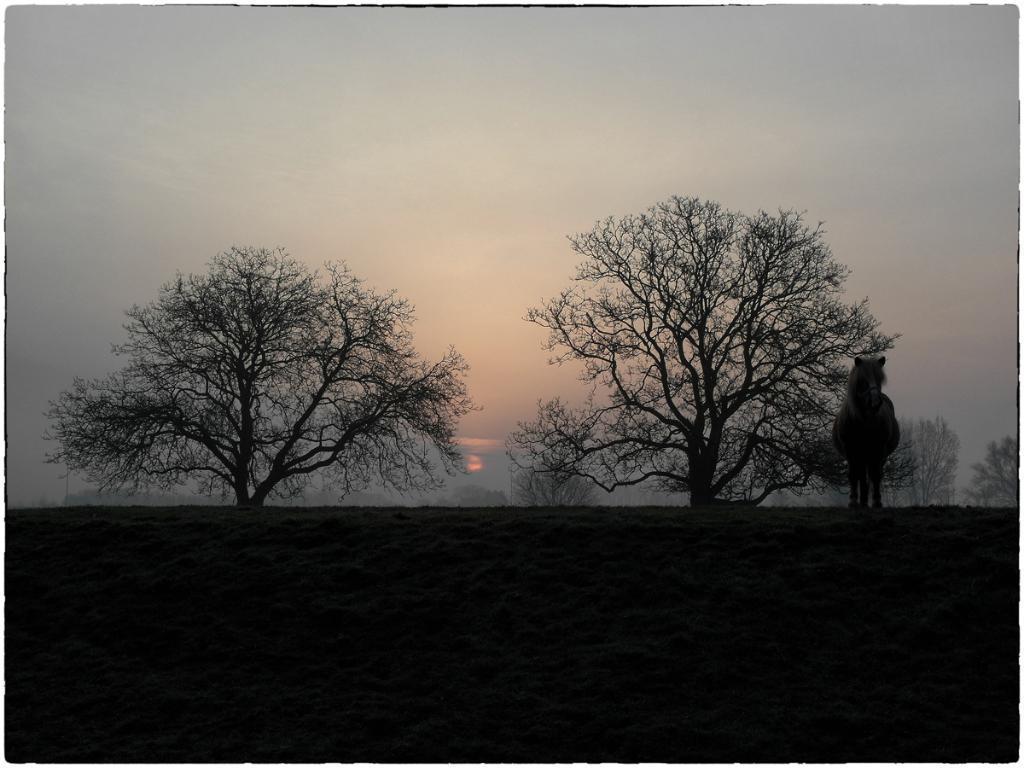Can you describe this image briefly? In the foreground I can see a horse is standing on the ground. In the background I can see trees. On the top I can see the sky. This image is taken may be in the forest. 